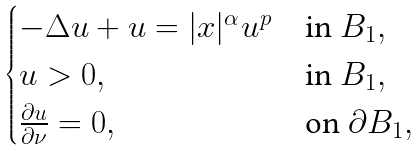<formula> <loc_0><loc_0><loc_500><loc_500>\begin{cases} - \Delta u + u = | x | ^ { \alpha } u ^ { p } & \text {in } B _ { 1 } , \\ u > 0 , & \text {in } B _ { 1 } , \\ \frac { \partial u } { \partial \nu } = 0 , & \text {on } \partial B _ { 1 } , \end{cases}</formula> 